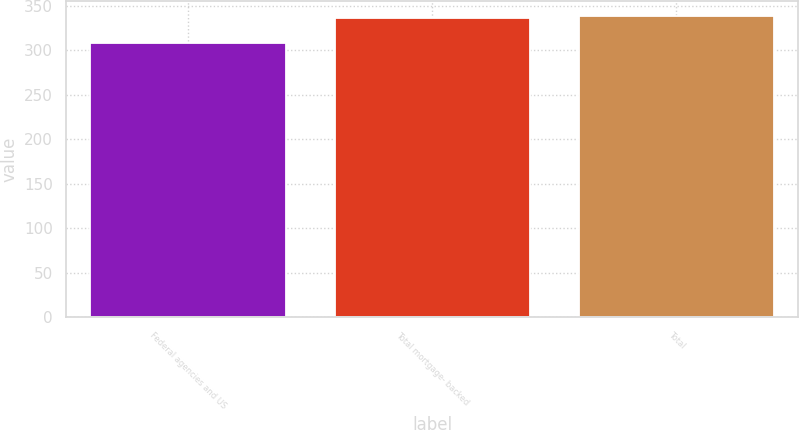<chart> <loc_0><loc_0><loc_500><loc_500><bar_chart><fcel>Federal agencies and US<fcel>Total mortgage- backed<fcel>Total<nl><fcel>308<fcel>336<fcel>338.8<nl></chart> 